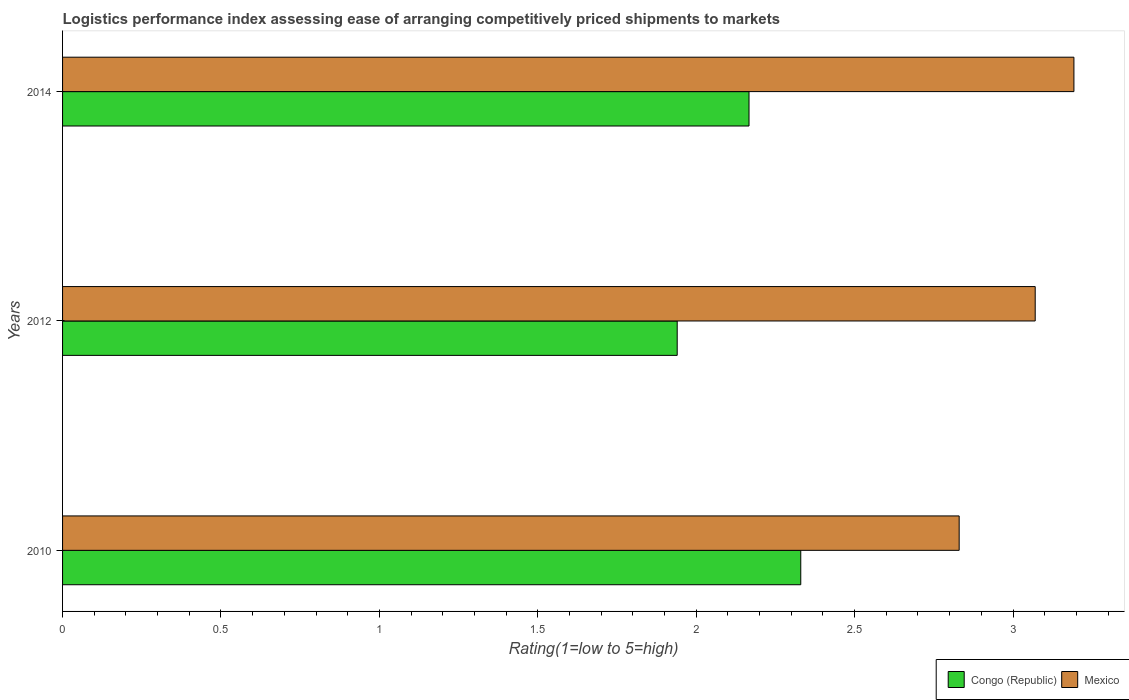How many different coloured bars are there?
Give a very brief answer. 2. How many groups of bars are there?
Your answer should be very brief. 3. Are the number of bars per tick equal to the number of legend labels?
Offer a terse response. Yes. How many bars are there on the 3rd tick from the top?
Offer a very short reply. 2. What is the label of the 1st group of bars from the top?
Make the answer very short. 2014. What is the Logistic performance index in Congo (Republic) in 2014?
Your answer should be compact. 2.17. Across all years, what is the maximum Logistic performance index in Congo (Republic)?
Give a very brief answer. 2.33. Across all years, what is the minimum Logistic performance index in Congo (Republic)?
Provide a short and direct response. 1.94. What is the total Logistic performance index in Congo (Republic) in the graph?
Offer a terse response. 6.44. What is the difference between the Logistic performance index in Mexico in 2010 and that in 2012?
Provide a short and direct response. -0.24. What is the difference between the Logistic performance index in Mexico in 2010 and the Logistic performance index in Congo (Republic) in 2012?
Offer a terse response. 0.89. What is the average Logistic performance index in Congo (Republic) per year?
Your answer should be compact. 2.15. In the year 2014, what is the difference between the Logistic performance index in Mexico and Logistic performance index in Congo (Republic)?
Your response must be concise. 1.03. In how many years, is the Logistic performance index in Congo (Republic) greater than 0.30000000000000004 ?
Your response must be concise. 3. What is the ratio of the Logistic performance index in Congo (Republic) in 2012 to that in 2014?
Your answer should be very brief. 0.9. Is the difference between the Logistic performance index in Mexico in 2010 and 2014 greater than the difference between the Logistic performance index in Congo (Republic) in 2010 and 2014?
Offer a terse response. No. What is the difference between the highest and the second highest Logistic performance index in Congo (Republic)?
Your response must be concise. 0.16. What is the difference between the highest and the lowest Logistic performance index in Mexico?
Keep it short and to the point. 0.36. In how many years, is the Logistic performance index in Mexico greater than the average Logistic performance index in Mexico taken over all years?
Offer a very short reply. 2. What does the 1st bar from the bottom in 2010 represents?
Make the answer very short. Congo (Republic). How many years are there in the graph?
Your answer should be compact. 3. What is the difference between two consecutive major ticks on the X-axis?
Ensure brevity in your answer.  0.5. Are the values on the major ticks of X-axis written in scientific E-notation?
Provide a short and direct response. No. Does the graph contain any zero values?
Give a very brief answer. No. Does the graph contain grids?
Provide a succinct answer. No. How many legend labels are there?
Make the answer very short. 2. How are the legend labels stacked?
Keep it short and to the point. Horizontal. What is the title of the graph?
Your response must be concise. Logistics performance index assessing ease of arranging competitively priced shipments to markets. Does "Iceland" appear as one of the legend labels in the graph?
Your answer should be very brief. No. What is the label or title of the X-axis?
Your answer should be very brief. Rating(1=low to 5=high). What is the label or title of the Y-axis?
Your response must be concise. Years. What is the Rating(1=low to 5=high) in Congo (Republic) in 2010?
Offer a very short reply. 2.33. What is the Rating(1=low to 5=high) of Mexico in 2010?
Give a very brief answer. 2.83. What is the Rating(1=low to 5=high) of Congo (Republic) in 2012?
Your answer should be compact. 1.94. What is the Rating(1=low to 5=high) in Mexico in 2012?
Provide a succinct answer. 3.07. What is the Rating(1=low to 5=high) in Congo (Republic) in 2014?
Offer a very short reply. 2.17. What is the Rating(1=low to 5=high) in Mexico in 2014?
Offer a very short reply. 3.19. Across all years, what is the maximum Rating(1=low to 5=high) in Congo (Republic)?
Your answer should be compact. 2.33. Across all years, what is the maximum Rating(1=low to 5=high) in Mexico?
Your answer should be compact. 3.19. Across all years, what is the minimum Rating(1=low to 5=high) of Congo (Republic)?
Offer a very short reply. 1.94. Across all years, what is the minimum Rating(1=low to 5=high) in Mexico?
Offer a terse response. 2.83. What is the total Rating(1=low to 5=high) of Congo (Republic) in the graph?
Make the answer very short. 6.44. What is the total Rating(1=low to 5=high) in Mexico in the graph?
Provide a succinct answer. 9.09. What is the difference between the Rating(1=low to 5=high) of Congo (Republic) in 2010 and that in 2012?
Provide a short and direct response. 0.39. What is the difference between the Rating(1=low to 5=high) in Mexico in 2010 and that in 2012?
Offer a very short reply. -0.24. What is the difference between the Rating(1=low to 5=high) of Congo (Republic) in 2010 and that in 2014?
Ensure brevity in your answer.  0.16. What is the difference between the Rating(1=low to 5=high) in Mexico in 2010 and that in 2014?
Your answer should be compact. -0.36. What is the difference between the Rating(1=low to 5=high) of Congo (Republic) in 2012 and that in 2014?
Your answer should be compact. -0.23. What is the difference between the Rating(1=low to 5=high) in Mexico in 2012 and that in 2014?
Provide a succinct answer. -0.12. What is the difference between the Rating(1=low to 5=high) of Congo (Republic) in 2010 and the Rating(1=low to 5=high) of Mexico in 2012?
Your answer should be very brief. -0.74. What is the difference between the Rating(1=low to 5=high) of Congo (Republic) in 2010 and the Rating(1=low to 5=high) of Mexico in 2014?
Give a very brief answer. -0.86. What is the difference between the Rating(1=low to 5=high) of Congo (Republic) in 2012 and the Rating(1=low to 5=high) of Mexico in 2014?
Keep it short and to the point. -1.25. What is the average Rating(1=low to 5=high) of Congo (Republic) per year?
Provide a succinct answer. 2.15. What is the average Rating(1=low to 5=high) in Mexico per year?
Keep it short and to the point. 3.03. In the year 2012, what is the difference between the Rating(1=low to 5=high) of Congo (Republic) and Rating(1=low to 5=high) of Mexico?
Your answer should be compact. -1.13. In the year 2014, what is the difference between the Rating(1=low to 5=high) of Congo (Republic) and Rating(1=low to 5=high) of Mexico?
Your response must be concise. -1.03. What is the ratio of the Rating(1=low to 5=high) in Congo (Republic) in 2010 to that in 2012?
Offer a terse response. 1.2. What is the ratio of the Rating(1=low to 5=high) in Mexico in 2010 to that in 2012?
Your answer should be compact. 0.92. What is the ratio of the Rating(1=low to 5=high) in Congo (Republic) in 2010 to that in 2014?
Keep it short and to the point. 1.08. What is the ratio of the Rating(1=low to 5=high) of Mexico in 2010 to that in 2014?
Provide a short and direct response. 0.89. What is the ratio of the Rating(1=low to 5=high) in Congo (Republic) in 2012 to that in 2014?
Your answer should be compact. 0.9. What is the ratio of the Rating(1=low to 5=high) in Mexico in 2012 to that in 2014?
Provide a short and direct response. 0.96. What is the difference between the highest and the second highest Rating(1=low to 5=high) of Congo (Republic)?
Make the answer very short. 0.16. What is the difference between the highest and the second highest Rating(1=low to 5=high) in Mexico?
Give a very brief answer. 0.12. What is the difference between the highest and the lowest Rating(1=low to 5=high) in Congo (Republic)?
Offer a very short reply. 0.39. What is the difference between the highest and the lowest Rating(1=low to 5=high) of Mexico?
Provide a succinct answer. 0.36. 